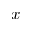Convert formula to latex. <formula><loc_0><loc_0><loc_500><loc_500>x</formula> 